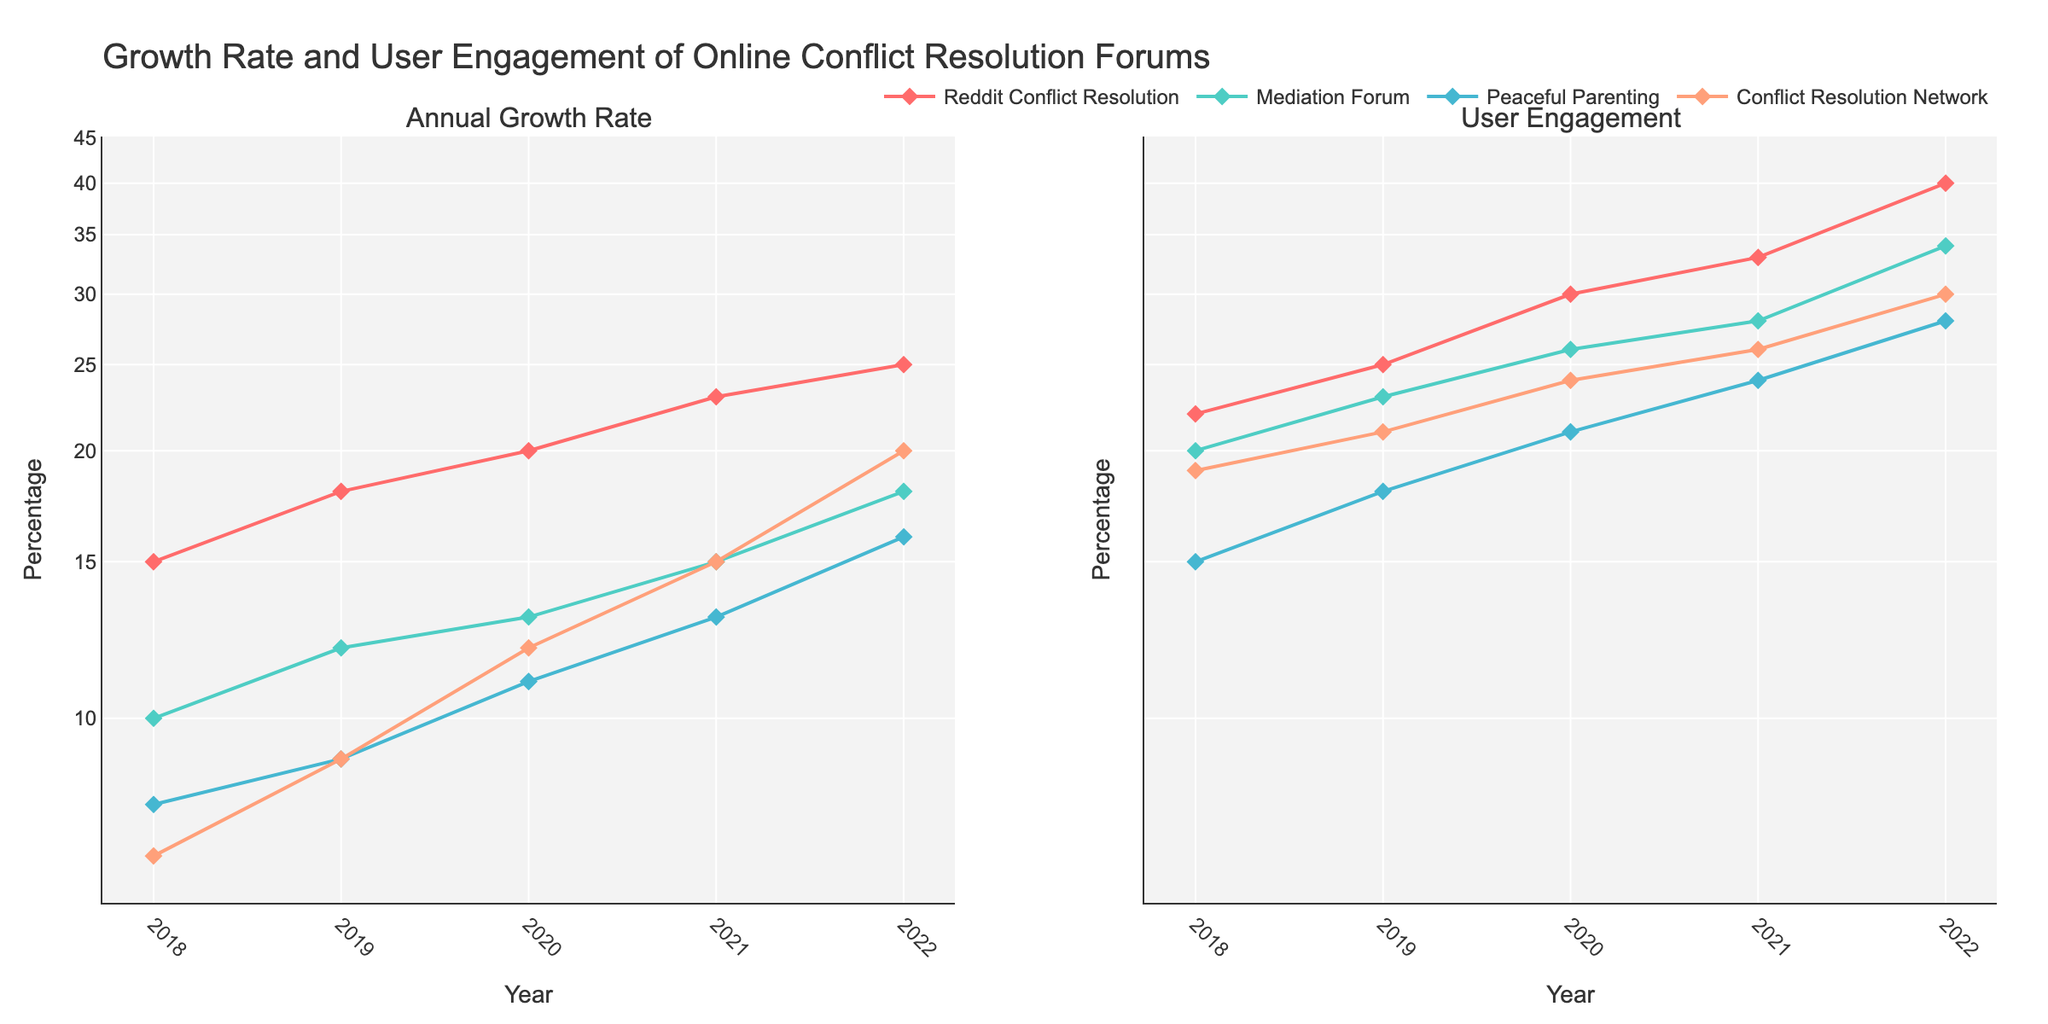What is the title of the figure? The title of the figure is usually placed at the top and typically describes the main subject of the plot. In this case, it states "Growth Rate and User Engagement of Online Conflict Resolution Forums".
Answer: Growth Rate and User Engagement of Online Conflict Resolution Forums How many forums are compared in the figure? By observing the number of different colored lines in both subplots and noting the legend entries, we can determine that there are four forums.
Answer: Four Which forum shows the highest Annual Growth Rate in the year 2022? Looking at the left subplot and identifying the highest point along the y-axis for the year 2022, we see that "Reddit Conflict Resolution" reaches the highest growth rate.
Answer: Reddit Conflict Resolution What is the annual growth rate of "Mediation Forum" in 2019? On the left subplot, find the point corresponding to "Mediation Forum" for the year 2019, then read the y-axis value.
Answer: 12% Does "Peaceful Parenting" display a continuous increase in User Engagement from 2018 to 2022? By following the "Peaceful Parenting" line on the right subplot across the years, we can see a consistent upward trend in User Engagement, indicating a continuous increase.
Answer: Yes Which forum experienced the largest increase in User Engagement from 2018 to 2022? To determine this, compare the difference in User Engagement values between 2022 and 2018 for each forum in the right subplot. "Reddit Conflict Resolution" appears to have the largest increase.
Answer: Reddit Conflict Resolution How does the log scale on the y-axis affect the way we interpret growth trends? The log scale compresses larger values while expanding smaller values, thereby emphasizing proportional growth rather than absolute differences. This makes it easier to compare rates of increase, especially for data that spans several orders of magnitude.
Answer: Emphasizes proportional growth Is the trend of Annual Growth Rate for "Conflict Resolution Network" directly proportional to its User Engagement over the years? First, observe the left subplot for the "Conflict Resolution Network" and note its growth trends. Then observe the right subplot for the same forum's User Engagement trends. While both increase, User Engagement grows more rapidly, indicating the trends are not directly proportional.
Answer: No What is the approximate User Engagement percentage for "Peaceful Parenting" in 2020? Find the year 2020 on the right subplot and trace the corresponding "Peaceful Parenting" point to the y-axis.
Answer: 21% 